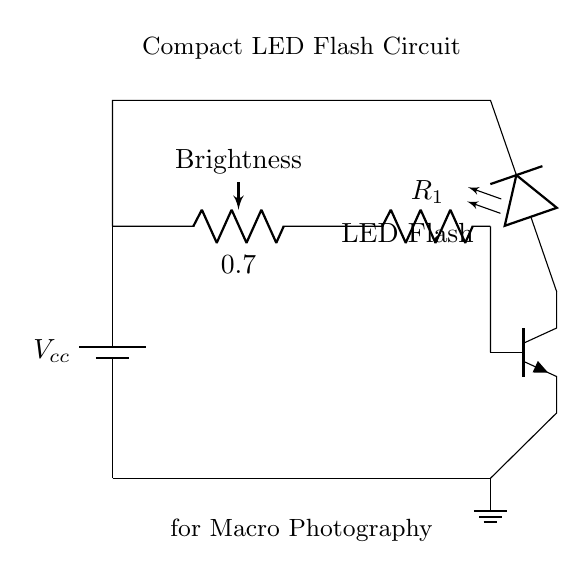What is the main power source in this circuit? The main power source is a battery which is depicted at the left side of the circuit diagram. This is critical for powering the entire circuit.
Answer: Battery What component controls the brightness of the LED? The brightness is controlled by a potentiometer, which is shown just after the battery in the diagram. This allows for adjustment based on user preference.
Answer: Potentiometer How many significant components are in the circuit? The significant components in the circuit include the battery, potentiometer, resistor, transistor, and LED. Counting these gives a total of five main components.
Answer: Five What type of transistor is used in the circuit? The circuit uses an NPN transistor, which is identified by the letters above the symbol in the diagram. This type allows for the control of current between the collector and emitter based on the base current.
Answer: NPN What is the purpose of the resistor in this circuit? The resistor, labeled as R1, limits the current flowing to the LED and helps in preventing damage. It plays a critical role in ensuring the LED operates safely within its rated parameters.
Answer: Current limiting What happens to the LED when the potentiometer is turned up? When the potentiometer is turned up, it increases the resistance, which in turn decreases the voltage drop across the LED, leading to increased brightness as more current flows through the LED.
Answer: Increases brightness What is the overall purpose of this compact LED flash circuit? The circuit is designed specifically to provide adjustable brightness for macro photography, allowing photographers to achieve optimal lighting conditions for close-up shots.
Answer: Macro photography 